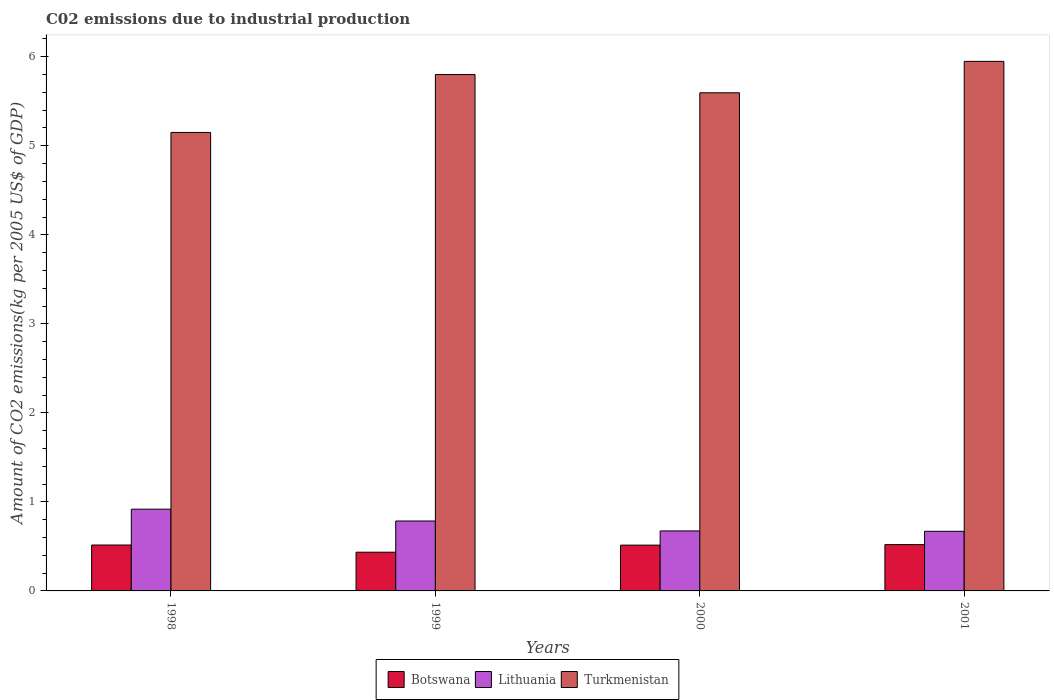Are the number of bars on each tick of the X-axis equal?
Your response must be concise. Yes. How many bars are there on the 4th tick from the left?
Provide a short and direct response. 3. How many bars are there on the 4th tick from the right?
Your response must be concise. 3. In how many cases, is the number of bars for a given year not equal to the number of legend labels?
Offer a terse response. 0. What is the amount of CO2 emitted due to industrial production in Botswana in 1999?
Provide a succinct answer. 0.44. Across all years, what is the maximum amount of CO2 emitted due to industrial production in Botswana?
Ensure brevity in your answer.  0.52. Across all years, what is the minimum amount of CO2 emitted due to industrial production in Botswana?
Offer a terse response. 0.44. In which year was the amount of CO2 emitted due to industrial production in Botswana minimum?
Your answer should be compact. 1999. What is the total amount of CO2 emitted due to industrial production in Lithuania in the graph?
Your response must be concise. 3.05. What is the difference between the amount of CO2 emitted due to industrial production in Lithuania in 1998 and that in 2001?
Offer a very short reply. 0.25. What is the difference between the amount of CO2 emitted due to industrial production in Lithuania in 2000 and the amount of CO2 emitted due to industrial production in Turkmenistan in 1999?
Offer a terse response. -5.13. What is the average amount of CO2 emitted due to industrial production in Botswana per year?
Keep it short and to the point. 0.5. In the year 2000, what is the difference between the amount of CO2 emitted due to industrial production in Botswana and amount of CO2 emitted due to industrial production in Turkmenistan?
Give a very brief answer. -5.08. What is the ratio of the amount of CO2 emitted due to industrial production in Turkmenistan in 1998 to that in 2001?
Provide a short and direct response. 0.87. Is the difference between the amount of CO2 emitted due to industrial production in Botswana in 1998 and 1999 greater than the difference between the amount of CO2 emitted due to industrial production in Turkmenistan in 1998 and 1999?
Give a very brief answer. Yes. What is the difference between the highest and the second highest amount of CO2 emitted due to industrial production in Turkmenistan?
Offer a very short reply. 0.15. What is the difference between the highest and the lowest amount of CO2 emitted due to industrial production in Botswana?
Provide a succinct answer. 0.09. In how many years, is the amount of CO2 emitted due to industrial production in Botswana greater than the average amount of CO2 emitted due to industrial production in Botswana taken over all years?
Your answer should be compact. 3. What does the 2nd bar from the left in 2001 represents?
Make the answer very short. Lithuania. What does the 2nd bar from the right in 1998 represents?
Make the answer very short. Lithuania. How many years are there in the graph?
Ensure brevity in your answer.  4. What is the difference between two consecutive major ticks on the Y-axis?
Keep it short and to the point. 1. How many legend labels are there?
Offer a terse response. 3. What is the title of the graph?
Offer a very short reply. C02 emissions due to industrial production. Does "Slovak Republic" appear as one of the legend labels in the graph?
Give a very brief answer. No. What is the label or title of the Y-axis?
Offer a very short reply. Amount of CO2 emissions(kg per 2005 US$ of GDP). What is the Amount of CO2 emissions(kg per 2005 US$ of GDP) in Botswana in 1998?
Your response must be concise. 0.52. What is the Amount of CO2 emissions(kg per 2005 US$ of GDP) in Lithuania in 1998?
Provide a short and direct response. 0.92. What is the Amount of CO2 emissions(kg per 2005 US$ of GDP) in Turkmenistan in 1998?
Make the answer very short. 5.15. What is the Amount of CO2 emissions(kg per 2005 US$ of GDP) in Botswana in 1999?
Give a very brief answer. 0.44. What is the Amount of CO2 emissions(kg per 2005 US$ of GDP) of Lithuania in 1999?
Your answer should be very brief. 0.79. What is the Amount of CO2 emissions(kg per 2005 US$ of GDP) of Turkmenistan in 1999?
Provide a succinct answer. 5.8. What is the Amount of CO2 emissions(kg per 2005 US$ of GDP) of Botswana in 2000?
Keep it short and to the point. 0.51. What is the Amount of CO2 emissions(kg per 2005 US$ of GDP) of Lithuania in 2000?
Your response must be concise. 0.67. What is the Amount of CO2 emissions(kg per 2005 US$ of GDP) of Turkmenistan in 2000?
Offer a very short reply. 5.6. What is the Amount of CO2 emissions(kg per 2005 US$ of GDP) of Botswana in 2001?
Your response must be concise. 0.52. What is the Amount of CO2 emissions(kg per 2005 US$ of GDP) of Lithuania in 2001?
Provide a short and direct response. 0.67. What is the Amount of CO2 emissions(kg per 2005 US$ of GDP) in Turkmenistan in 2001?
Give a very brief answer. 5.95. Across all years, what is the maximum Amount of CO2 emissions(kg per 2005 US$ of GDP) of Botswana?
Give a very brief answer. 0.52. Across all years, what is the maximum Amount of CO2 emissions(kg per 2005 US$ of GDP) in Lithuania?
Ensure brevity in your answer.  0.92. Across all years, what is the maximum Amount of CO2 emissions(kg per 2005 US$ of GDP) in Turkmenistan?
Keep it short and to the point. 5.95. Across all years, what is the minimum Amount of CO2 emissions(kg per 2005 US$ of GDP) of Botswana?
Offer a very short reply. 0.44. Across all years, what is the minimum Amount of CO2 emissions(kg per 2005 US$ of GDP) in Lithuania?
Offer a very short reply. 0.67. Across all years, what is the minimum Amount of CO2 emissions(kg per 2005 US$ of GDP) of Turkmenistan?
Your answer should be very brief. 5.15. What is the total Amount of CO2 emissions(kg per 2005 US$ of GDP) in Botswana in the graph?
Your answer should be very brief. 1.99. What is the total Amount of CO2 emissions(kg per 2005 US$ of GDP) in Lithuania in the graph?
Keep it short and to the point. 3.05. What is the total Amount of CO2 emissions(kg per 2005 US$ of GDP) of Turkmenistan in the graph?
Your response must be concise. 22.49. What is the difference between the Amount of CO2 emissions(kg per 2005 US$ of GDP) in Botswana in 1998 and that in 1999?
Your answer should be compact. 0.08. What is the difference between the Amount of CO2 emissions(kg per 2005 US$ of GDP) in Lithuania in 1998 and that in 1999?
Make the answer very short. 0.13. What is the difference between the Amount of CO2 emissions(kg per 2005 US$ of GDP) of Turkmenistan in 1998 and that in 1999?
Your response must be concise. -0.65. What is the difference between the Amount of CO2 emissions(kg per 2005 US$ of GDP) of Botswana in 1998 and that in 2000?
Ensure brevity in your answer.  0. What is the difference between the Amount of CO2 emissions(kg per 2005 US$ of GDP) of Lithuania in 1998 and that in 2000?
Ensure brevity in your answer.  0.24. What is the difference between the Amount of CO2 emissions(kg per 2005 US$ of GDP) of Turkmenistan in 1998 and that in 2000?
Your response must be concise. -0.45. What is the difference between the Amount of CO2 emissions(kg per 2005 US$ of GDP) of Botswana in 1998 and that in 2001?
Your response must be concise. -0. What is the difference between the Amount of CO2 emissions(kg per 2005 US$ of GDP) in Lithuania in 1998 and that in 2001?
Offer a terse response. 0.25. What is the difference between the Amount of CO2 emissions(kg per 2005 US$ of GDP) of Turkmenistan in 1998 and that in 2001?
Give a very brief answer. -0.8. What is the difference between the Amount of CO2 emissions(kg per 2005 US$ of GDP) in Botswana in 1999 and that in 2000?
Your answer should be very brief. -0.08. What is the difference between the Amount of CO2 emissions(kg per 2005 US$ of GDP) in Lithuania in 1999 and that in 2000?
Make the answer very short. 0.11. What is the difference between the Amount of CO2 emissions(kg per 2005 US$ of GDP) of Turkmenistan in 1999 and that in 2000?
Ensure brevity in your answer.  0.2. What is the difference between the Amount of CO2 emissions(kg per 2005 US$ of GDP) of Botswana in 1999 and that in 2001?
Offer a very short reply. -0.09. What is the difference between the Amount of CO2 emissions(kg per 2005 US$ of GDP) of Lithuania in 1999 and that in 2001?
Your answer should be very brief. 0.12. What is the difference between the Amount of CO2 emissions(kg per 2005 US$ of GDP) in Turkmenistan in 1999 and that in 2001?
Provide a succinct answer. -0.15. What is the difference between the Amount of CO2 emissions(kg per 2005 US$ of GDP) in Botswana in 2000 and that in 2001?
Your answer should be compact. -0.01. What is the difference between the Amount of CO2 emissions(kg per 2005 US$ of GDP) of Lithuania in 2000 and that in 2001?
Ensure brevity in your answer.  0. What is the difference between the Amount of CO2 emissions(kg per 2005 US$ of GDP) in Turkmenistan in 2000 and that in 2001?
Make the answer very short. -0.35. What is the difference between the Amount of CO2 emissions(kg per 2005 US$ of GDP) in Botswana in 1998 and the Amount of CO2 emissions(kg per 2005 US$ of GDP) in Lithuania in 1999?
Give a very brief answer. -0.27. What is the difference between the Amount of CO2 emissions(kg per 2005 US$ of GDP) of Botswana in 1998 and the Amount of CO2 emissions(kg per 2005 US$ of GDP) of Turkmenistan in 1999?
Make the answer very short. -5.28. What is the difference between the Amount of CO2 emissions(kg per 2005 US$ of GDP) in Lithuania in 1998 and the Amount of CO2 emissions(kg per 2005 US$ of GDP) in Turkmenistan in 1999?
Offer a terse response. -4.88. What is the difference between the Amount of CO2 emissions(kg per 2005 US$ of GDP) in Botswana in 1998 and the Amount of CO2 emissions(kg per 2005 US$ of GDP) in Lithuania in 2000?
Provide a short and direct response. -0.16. What is the difference between the Amount of CO2 emissions(kg per 2005 US$ of GDP) in Botswana in 1998 and the Amount of CO2 emissions(kg per 2005 US$ of GDP) in Turkmenistan in 2000?
Give a very brief answer. -5.08. What is the difference between the Amount of CO2 emissions(kg per 2005 US$ of GDP) of Lithuania in 1998 and the Amount of CO2 emissions(kg per 2005 US$ of GDP) of Turkmenistan in 2000?
Your response must be concise. -4.68. What is the difference between the Amount of CO2 emissions(kg per 2005 US$ of GDP) in Botswana in 1998 and the Amount of CO2 emissions(kg per 2005 US$ of GDP) in Lithuania in 2001?
Make the answer very short. -0.15. What is the difference between the Amount of CO2 emissions(kg per 2005 US$ of GDP) of Botswana in 1998 and the Amount of CO2 emissions(kg per 2005 US$ of GDP) of Turkmenistan in 2001?
Keep it short and to the point. -5.43. What is the difference between the Amount of CO2 emissions(kg per 2005 US$ of GDP) in Lithuania in 1998 and the Amount of CO2 emissions(kg per 2005 US$ of GDP) in Turkmenistan in 2001?
Your answer should be very brief. -5.03. What is the difference between the Amount of CO2 emissions(kg per 2005 US$ of GDP) of Botswana in 1999 and the Amount of CO2 emissions(kg per 2005 US$ of GDP) of Lithuania in 2000?
Give a very brief answer. -0.24. What is the difference between the Amount of CO2 emissions(kg per 2005 US$ of GDP) in Botswana in 1999 and the Amount of CO2 emissions(kg per 2005 US$ of GDP) in Turkmenistan in 2000?
Give a very brief answer. -5.16. What is the difference between the Amount of CO2 emissions(kg per 2005 US$ of GDP) of Lithuania in 1999 and the Amount of CO2 emissions(kg per 2005 US$ of GDP) of Turkmenistan in 2000?
Give a very brief answer. -4.81. What is the difference between the Amount of CO2 emissions(kg per 2005 US$ of GDP) of Botswana in 1999 and the Amount of CO2 emissions(kg per 2005 US$ of GDP) of Lithuania in 2001?
Give a very brief answer. -0.23. What is the difference between the Amount of CO2 emissions(kg per 2005 US$ of GDP) of Botswana in 1999 and the Amount of CO2 emissions(kg per 2005 US$ of GDP) of Turkmenistan in 2001?
Make the answer very short. -5.51. What is the difference between the Amount of CO2 emissions(kg per 2005 US$ of GDP) of Lithuania in 1999 and the Amount of CO2 emissions(kg per 2005 US$ of GDP) of Turkmenistan in 2001?
Provide a short and direct response. -5.16. What is the difference between the Amount of CO2 emissions(kg per 2005 US$ of GDP) in Botswana in 2000 and the Amount of CO2 emissions(kg per 2005 US$ of GDP) in Lithuania in 2001?
Provide a short and direct response. -0.16. What is the difference between the Amount of CO2 emissions(kg per 2005 US$ of GDP) of Botswana in 2000 and the Amount of CO2 emissions(kg per 2005 US$ of GDP) of Turkmenistan in 2001?
Offer a terse response. -5.43. What is the difference between the Amount of CO2 emissions(kg per 2005 US$ of GDP) in Lithuania in 2000 and the Amount of CO2 emissions(kg per 2005 US$ of GDP) in Turkmenistan in 2001?
Offer a terse response. -5.27. What is the average Amount of CO2 emissions(kg per 2005 US$ of GDP) in Botswana per year?
Provide a short and direct response. 0.5. What is the average Amount of CO2 emissions(kg per 2005 US$ of GDP) in Lithuania per year?
Your response must be concise. 0.76. What is the average Amount of CO2 emissions(kg per 2005 US$ of GDP) in Turkmenistan per year?
Give a very brief answer. 5.62. In the year 1998, what is the difference between the Amount of CO2 emissions(kg per 2005 US$ of GDP) in Botswana and Amount of CO2 emissions(kg per 2005 US$ of GDP) in Lithuania?
Provide a succinct answer. -0.4. In the year 1998, what is the difference between the Amount of CO2 emissions(kg per 2005 US$ of GDP) in Botswana and Amount of CO2 emissions(kg per 2005 US$ of GDP) in Turkmenistan?
Keep it short and to the point. -4.63. In the year 1998, what is the difference between the Amount of CO2 emissions(kg per 2005 US$ of GDP) in Lithuania and Amount of CO2 emissions(kg per 2005 US$ of GDP) in Turkmenistan?
Ensure brevity in your answer.  -4.23. In the year 1999, what is the difference between the Amount of CO2 emissions(kg per 2005 US$ of GDP) in Botswana and Amount of CO2 emissions(kg per 2005 US$ of GDP) in Lithuania?
Offer a terse response. -0.35. In the year 1999, what is the difference between the Amount of CO2 emissions(kg per 2005 US$ of GDP) in Botswana and Amount of CO2 emissions(kg per 2005 US$ of GDP) in Turkmenistan?
Offer a terse response. -5.37. In the year 1999, what is the difference between the Amount of CO2 emissions(kg per 2005 US$ of GDP) of Lithuania and Amount of CO2 emissions(kg per 2005 US$ of GDP) of Turkmenistan?
Your response must be concise. -5.02. In the year 2000, what is the difference between the Amount of CO2 emissions(kg per 2005 US$ of GDP) in Botswana and Amount of CO2 emissions(kg per 2005 US$ of GDP) in Lithuania?
Provide a succinct answer. -0.16. In the year 2000, what is the difference between the Amount of CO2 emissions(kg per 2005 US$ of GDP) in Botswana and Amount of CO2 emissions(kg per 2005 US$ of GDP) in Turkmenistan?
Your response must be concise. -5.08. In the year 2000, what is the difference between the Amount of CO2 emissions(kg per 2005 US$ of GDP) in Lithuania and Amount of CO2 emissions(kg per 2005 US$ of GDP) in Turkmenistan?
Ensure brevity in your answer.  -4.92. In the year 2001, what is the difference between the Amount of CO2 emissions(kg per 2005 US$ of GDP) in Botswana and Amount of CO2 emissions(kg per 2005 US$ of GDP) in Lithuania?
Offer a very short reply. -0.15. In the year 2001, what is the difference between the Amount of CO2 emissions(kg per 2005 US$ of GDP) of Botswana and Amount of CO2 emissions(kg per 2005 US$ of GDP) of Turkmenistan?
Offer a terse response. -5.43. In the year 2001, what is the difference between the Amount of CO2 emissions(kg per 2005 US$ of GDP) in Lithuania and Amount of CO2 emissions(kg per 2005 US$ of GDP) in Turkmenistan?
Provide a short and direct response. -5.28. What is the ratio of the Amount of CO2 emissions(kg per 2005 US$ of GDP) in Botswana in 1998 to that in 1999?
Provide a short and direct response. 1.19. What is the ratio of the Amount of CO2 emissions(kg per 2005 US$ of GDP) in Lithuania in 1998 to that in 1999?
Provide a short and direct response. 1.17. What is the ratio of the Amount of CO2 emissions(kg per 2005 US$ of GDP) in Turkmenistan in 1998 to that in 1999?
Provide a short and direct response. 0.89. What is the ratio of the Amount of CO2 emissions(kg per 2005 US$ of GDP) in Lithuania in 1998 to that in 2000?
Your answer should be very brief. 1.36. What is the ratio of the Amount of CO2 emissions(kg per 2005 US$ of GDP) of Turkmenistan in 1998 to that in 2000?
Keep it short and to the point. 0.92. What is the ratio of the Amount of CO2 emissions(kg per 2005 US$ of GDP) of Lithuania in 1998 to that in 2001?
Offer a terse response. 1.37. What is the ratio of the Amount of CO2 emissions(kg per 2005 US$ of GDP) in Turkmenistan in 1998 to that in 2001?
Offer a terse response. 0.87. What is the ratio of the Amount of CO2 emissions(kg per 2005 US$ of GDP) in Botswana in 1999 to that in 2000?
Offer a very short reply. 0.85. What is the ratio of the Amount of CO2 emissions(kg per 2005 US$ of GDP) of Lithuania in 1999 to that in 2000?
Provide a short and direct response. 1.17. What is the ratio of the Amount of CO2 emissions(kg per 2005 US$ of GDP) in Turkmenistan in 1999 to that in 2000?
Your answer should be very brief. 1.04. What is the ratio of the Amount of CO2 emissions(kg per 2005 US$ of GDP) in Botswana in 1999 to that in 2001?
Keep it short and to the point. 0.84. What is the ratio of the Amount of CO2 emissions(kg per 2005 US$ of GDP) of Lithuania in 1999 to that in 2001?
Give a very brief answer. 1.17. What is the ratio of the Amount of CO2 emissions(kg per 2005 US$ of GDP) of Turkmenistan in 1999 to that in 2001?
Ensure brevity in your answer.  0.98. What is the ratio of the Amount of CO2 emissions(kg per 2005 US$ of GDP) of Botswana in 2000 to that in 2001?
Make the answer very short. 0.99. What is the ratio of the Amount of CO2 emissions(kg per 2005 US$ of GDP) of Turkmenistan in 2000 to that in 2001?
Give a very brief answer. 0.94. What is the difference between the highest and the second highest Amount of CO2 emissions(kg per 2005 US$ of GDP) of Botswana?
Provide a short and direct response. 0. What is the difference between the highest and the second highest Amount of CO2 emissions(kg per 2005 US$ of GDP) in Lithuania?
Your answer should be very brief. 0.13. What is the difference between the highest and the second highest Amount of CO2 emissions(kg per 2005 US$ of GDP) of Turkmenistan?
Provide a succinct answer. 0.15. What is the difference between the highest and the lowest Amount of CO2 emissions(kg per 2005 US$ of GDP) of Botswana?
Your answer should be compact. 0.09. What is the difference between the highest and the lowest Amount of CO2 emissions(kg per 2005 US$ of GDP) in Lithuania?
Ensure brevity in your answer.  0.25. What is the difference between the highest and the lowest Amount of CO2 emissions(kg per 2005 US$ of GDP) in Turkmenistan?
Keep it short and to the point. 0.8. 